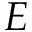<formula> <loc_0><loc_0><loc_500><loc_500>E</formula> 